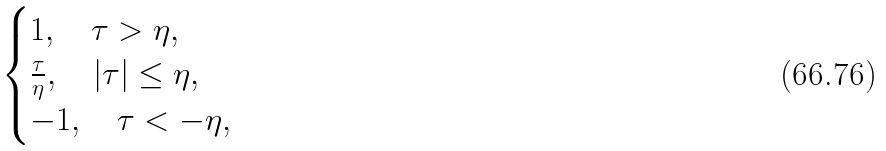<formula> <loc_0><loc_0><loc_500><loc_500>\begin{cases} 1 , \quad \tau > \eta , \\ \frac { \tau } { \eta } , \quad | \tau | \leq \eta , \\ - 1 , \quad \tau < - \eta , \end{cases}</formula> 